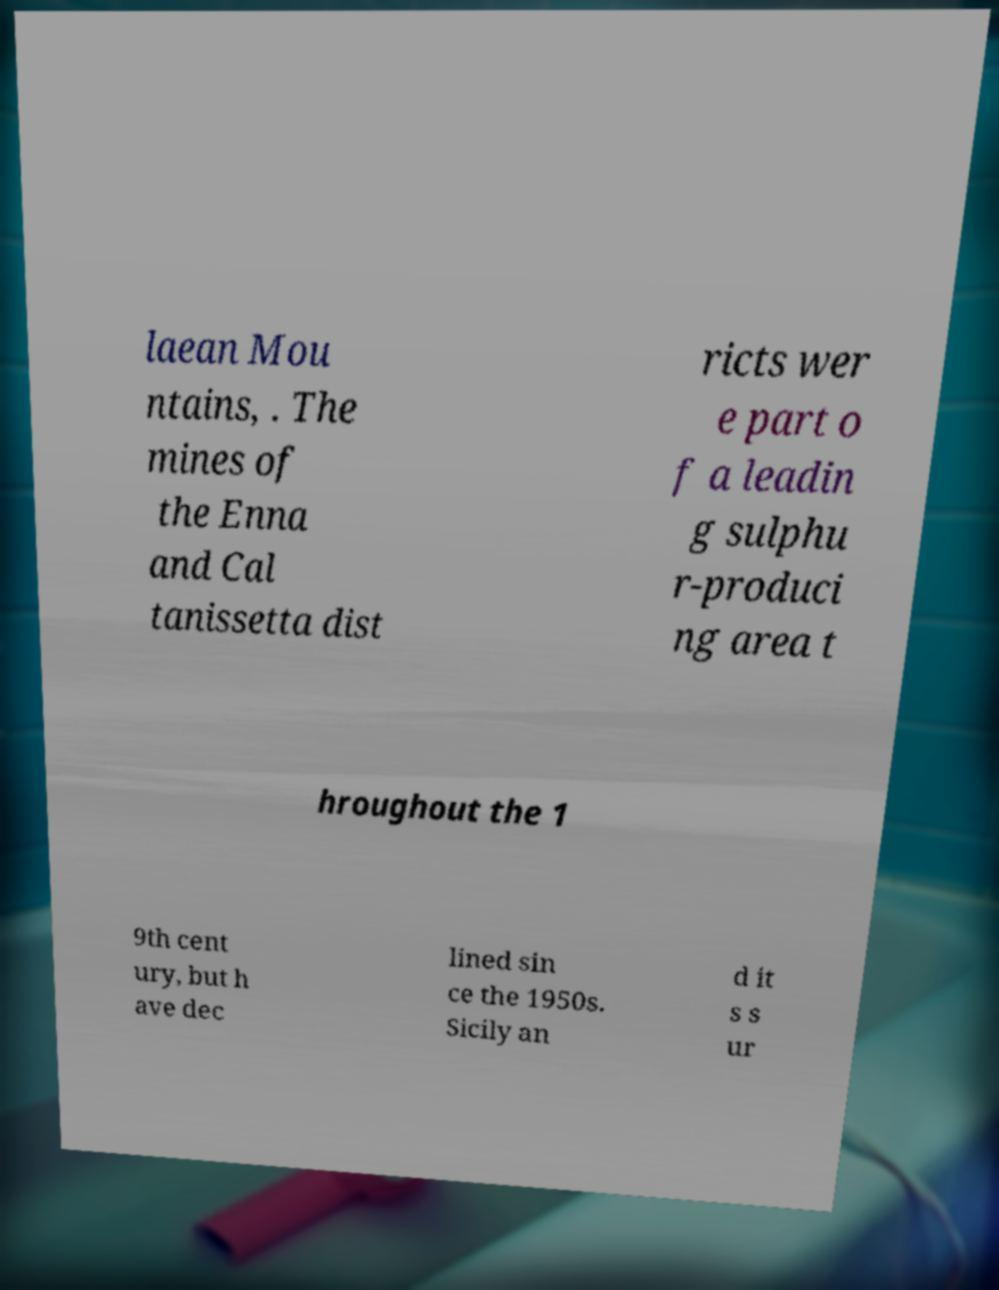There's text embedded in this image that I need extracted. Can you transcribe it verbatim? laean Mou ntains, . The mines of the Enna and Cal tanissetta dist ricts wer e part o f a leadin g sulphu r-produci ng area t hroughout the 1 9th cent ury, but h ave dec lined sin ce the 1950s. Sicily an d it s s ur 